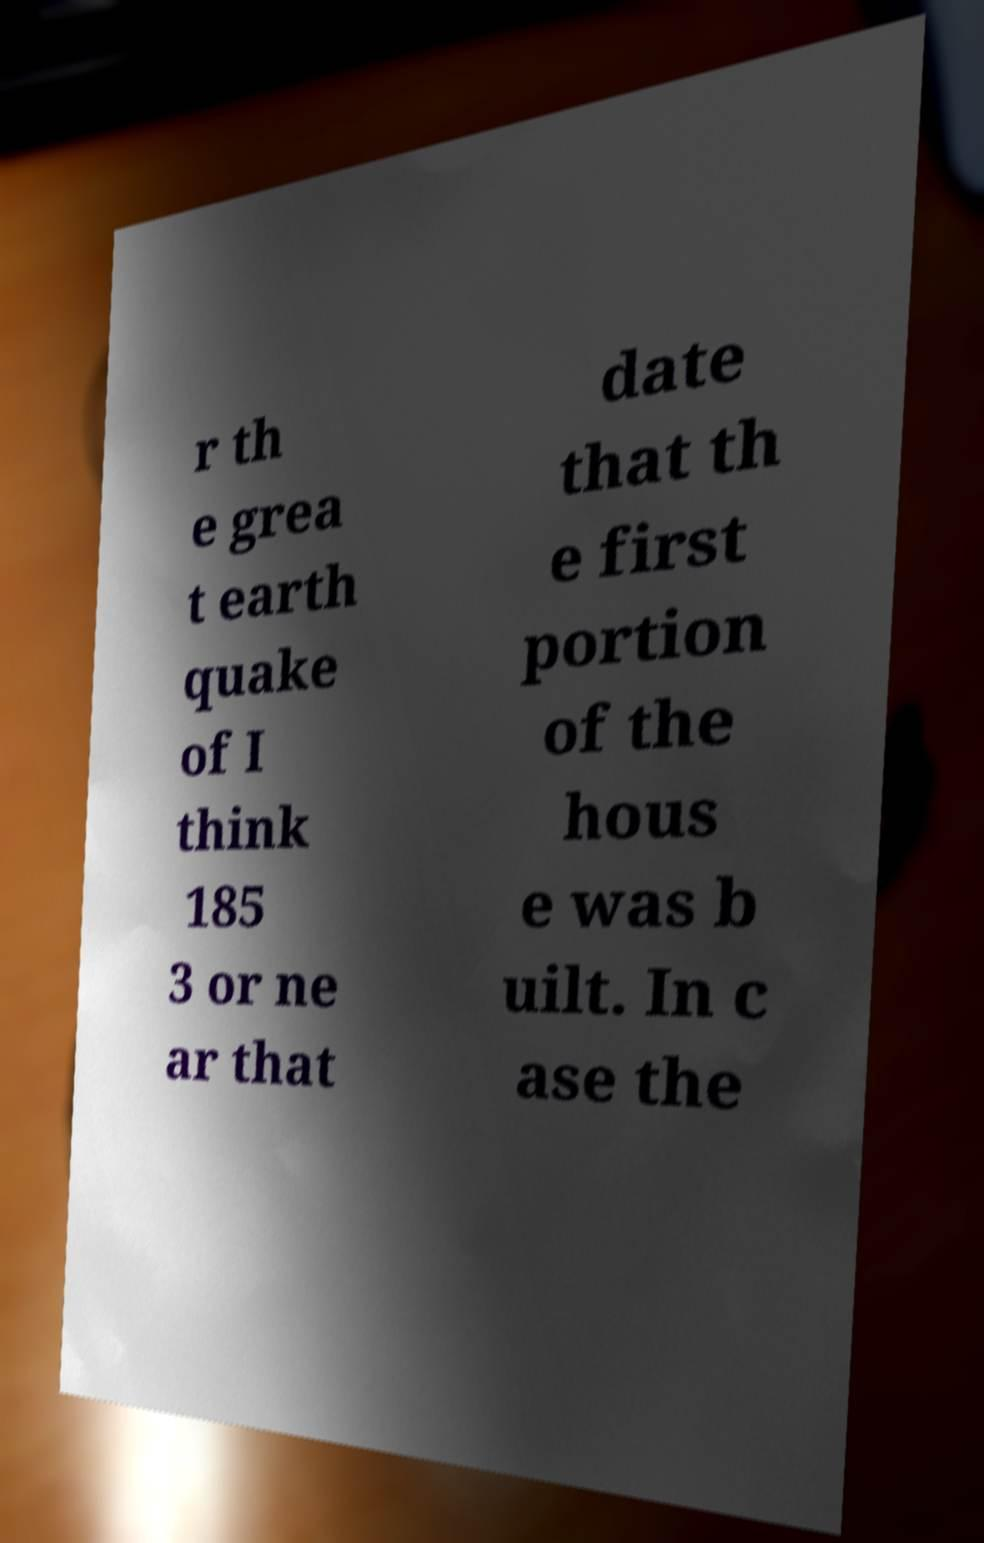Could you assist in decoding the text presented in this image and type it out clearly? r th e grea t earth quake of I think 185 3 or ne ar that date that th e first portion of the hous e was b uilt. In c ase the 